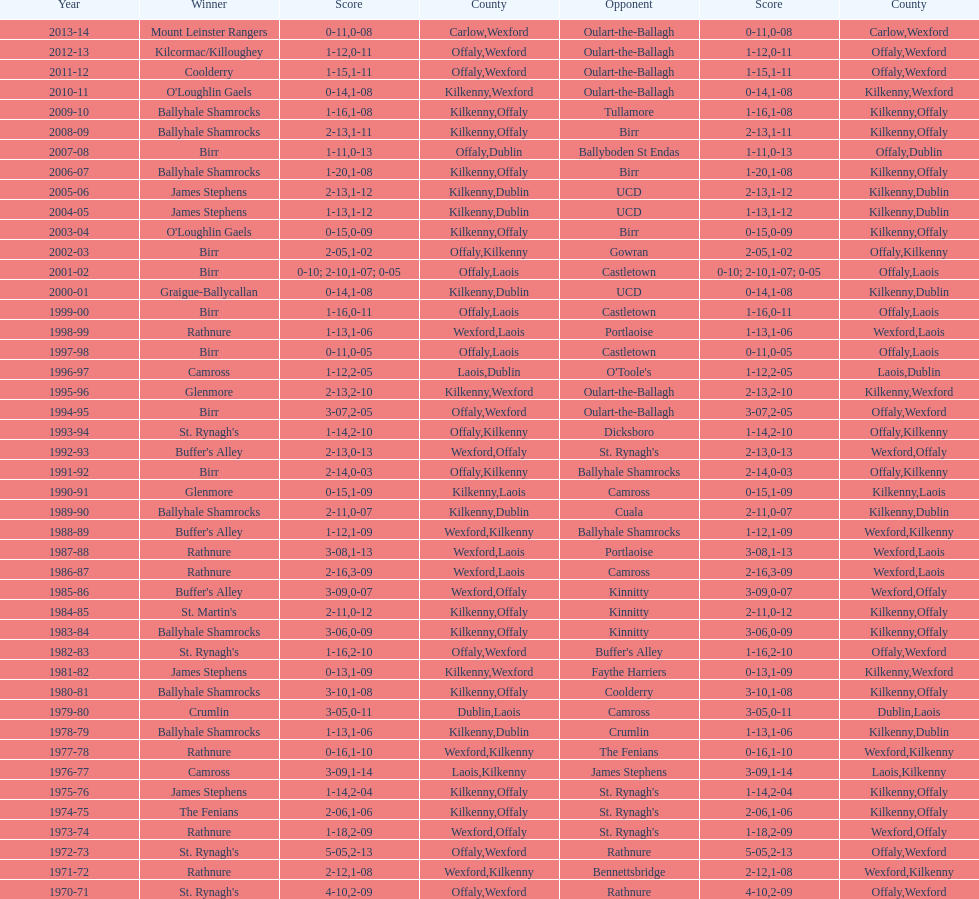Which team emerged victorious in the leinster senior club hurling championships prior to birr's most recent win? Ballyhale Shamrocks. 